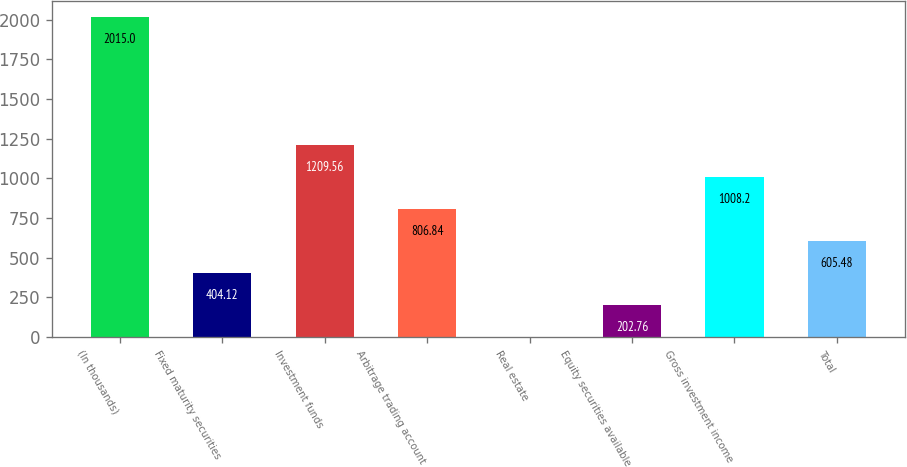<chart> <loc_0><loc_0><loc_500><loc_500><bar_chart><fcel>(In thousands)<fcel>Fixed maturity securities<fcel>Investment funds<fcel>Arbitrage trading account<fcel>Real estate<fcel>Equity securities available<fcel>Gross investment income<fcel>Total<nl><fcel>2015<fcel>404.12<fcel>1209.56<fcel>806.84<fcel>1.4<fcel>202.76<fcel>1008.2<fcel>605.48<nl></chart> 